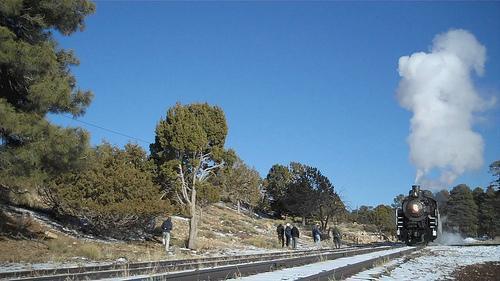How many people are there?
Give a very brief answer. 5. How many trains are in the scene?
Give a very brief answer. 1. 